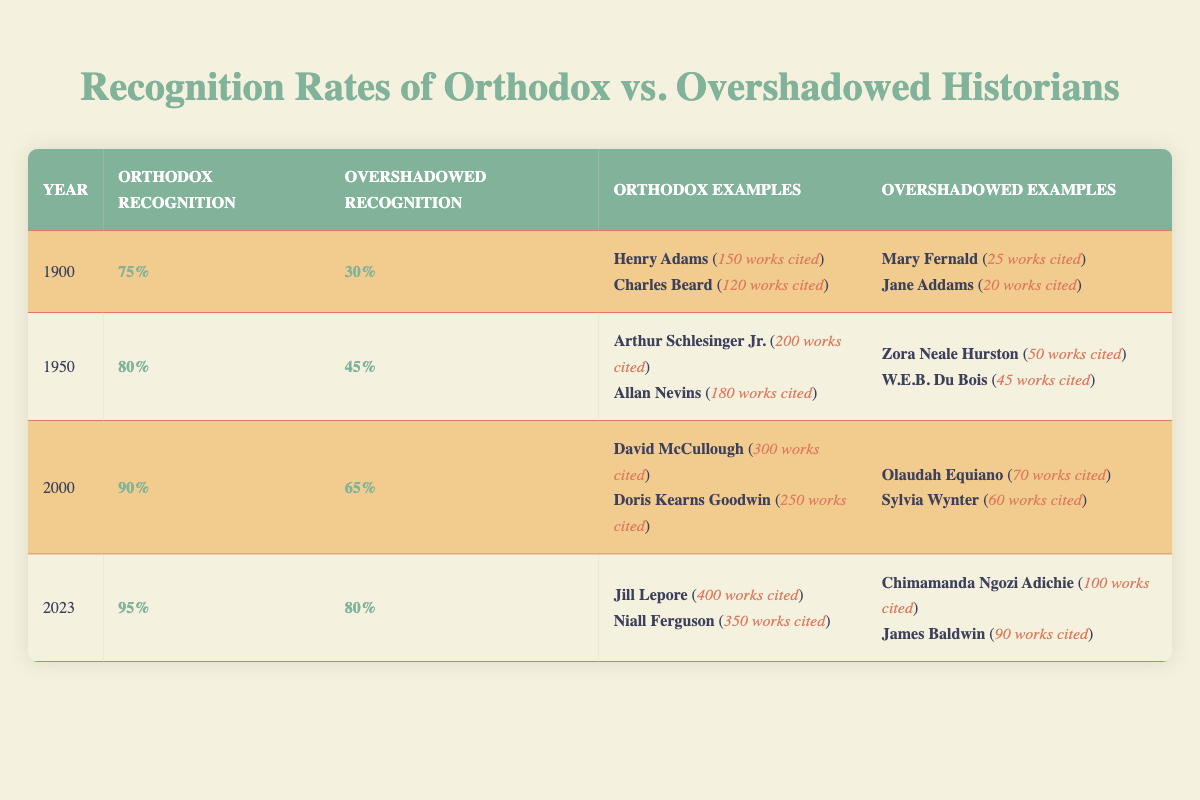What was the recognition rate for orthodox historians in 1950? The table shows that the recognition rate for orthodox historians in 1950 is listed as 80%.
Answer: 80% What is the difference in recognition rates between orthodox and overshadowed historians in 2000? In 2000, the recognition rate for orthodox historians is 90% and for overshadowed historians is 65%. The difference is calculated as 90% - 65% = 25%.
Answer: 25% Did Jane Addams have more works cited than W.E.B. Du Bois in 1950? The table indicates that Jane Addams had 20 works cited while W.E.B. Du Bois had 45 works cited in 1950. Since 20 is less than 45, the answer is no.
Answer: No In which year did overshadowed historians first exceed 50% recognition? The table shows that overshadowed historians reached 50% recognition for the first time in 2000 with a recognition rate of 65%. Prior to that, in 1950, their recognition was 45%.
Answer: 2000 What is the average recognition rate of overshadowed historians across all years? The recognition rates for overshadowed historians across the years are 30% (1900), 45% (1950), 65% (2000), and 80% (2023). To find the average, sum these percentages: 30 + 45 + 65 + 80 = 220 and divide by 4 (the number of years), which gives an average of 220/4 = 55%.
Answer: 55% 